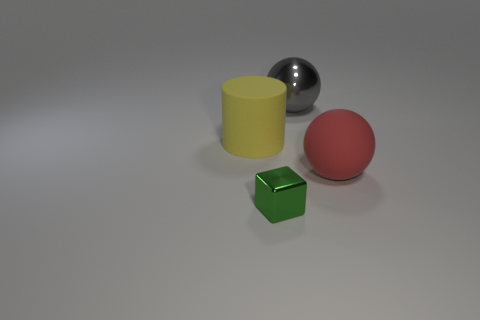Is the number of small objects less than the number of large brown shiny things?
Your answer should be very brief. No. What is the shape of the shiny thing that is on the right side of the metallic thing in front of the big sphere behind the big red ball?
Provide a short and direct response. Sphere. Are there any shiny balls?
Give a very brief answer. Yes. There is a gray ball; is it the same size as the cylinder in front of the large gray shiny sphere?
Your answer should be compact. Yes. Are there any small shiny blocks behind the sphere on the left side of the rubber sphere?
Offer a very short reply. No. What is the material of the object that is behind the large red matte thing and right of the yellow cylinder?
Give a very brief answer. Metal. What is the color of the ball that is in front of the rubber object that is left of the metallic object that is in front of the large gray object?
Ensure brevity in your answer.  Red. What color is the matte sphere that is the same size as the yellow rubber cylinder?
Ensure brevity in your answer.  Red. What is the material of the ball behind the matte thing right of the cube?
Offer a terse response. Metal. How many big objects are both right of the shiny cube and on the left side of the small thing?
Give a very brief answer. 0. 